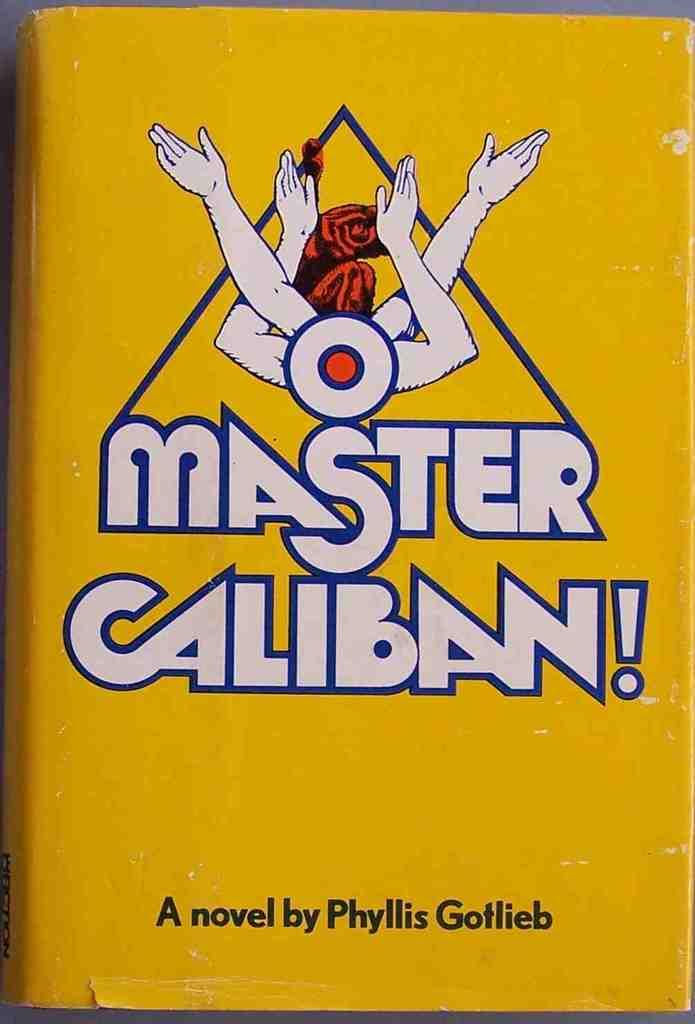<image>
Relay a brief, clear account of the picture shown. A novel with a bright yellow cover is written by Phyllis Gotlieb. 